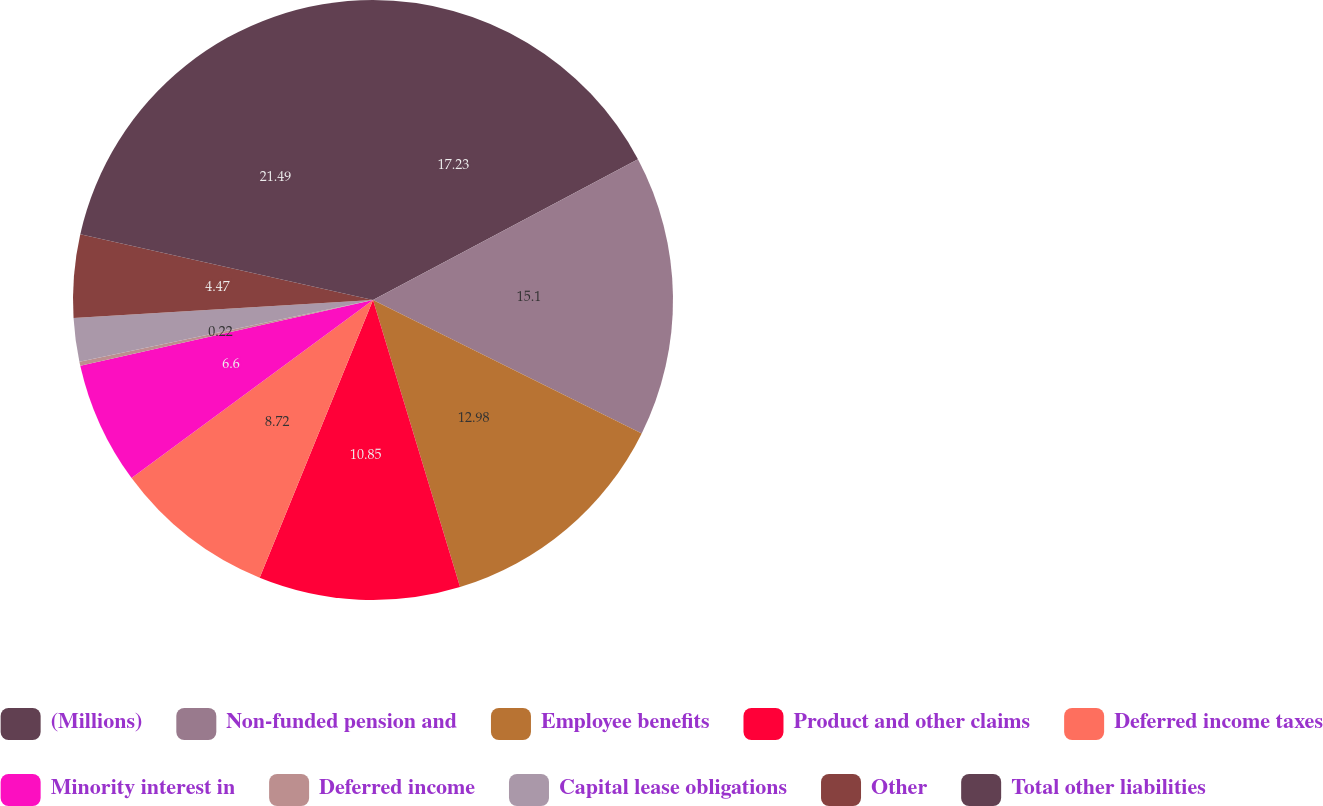Convert chart to OTSL. <chart><loc_0><loc_0><loc_500><loc_500><pie_chart><fcel>(Millions)<fcel>Non-funded pension and<fcel>Employee benefits<fcel>Product and other claims<fcel>Deferred income taxes<fcel>Minority interest in<fcel>Deferred income<fcel>Capital lease obligations<fcel>Other<fcel>Total other liabilities<nl><fcel>17.23%<fcel>15.1%<fcel>12.98%<fcel>10.85%<fcel>8.72%<fcel>6.6%<fcel>0.22%<fcel>2.34%<fcel>4.47%<fcel>21.48%<nl></chart> 